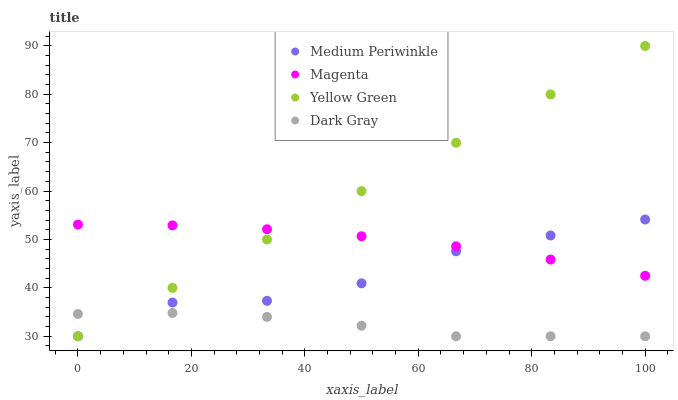Does Dark Gray have the minimum area under the curve?
Answer yes or no. Yes. Does Yellow Green have the maximum area under the curve?
Answer yes or no. Yes. Does Magenta have the minimum area under the curve?
Answer yes or no. No. Does Magenta have the maximum area under the curve?
Answer yes or no. No. Is Yellow Green the smoothest?
Answer yes or no. Yes. Is Medium Periwinkle the roughest?
Answer yes or no. Yes. Is Magenta the smoothest?
Answer yes or no. No. Is Magenta the roughest?
Answer yes or no. No. Does Dark Gray have the lowest value?
Answer yes or no. Yes. Does Magenta have the lowest value?
Answer yes or no. No. Does Yellow Green have the highest value?
Answer yes or no. Yes. Does Magenta have the highest value?
Answer yes or no. No. Is Dark Gray less than Magenta?
Answer yes or no. Yes. Is Magenta greater than Dark Gray?
Answer yes or no. Yes. Does Dark Gray intersect Yellow Green?
Answer yes or no. Yes. Is Dark Gray less than Yellow Green?
Answer yes or no. No. Is Dark Gray greater than Yellow Green?
Answer yes or no. No. Does Dark Gray intersect Magenta?
Answer yes or no. No. 